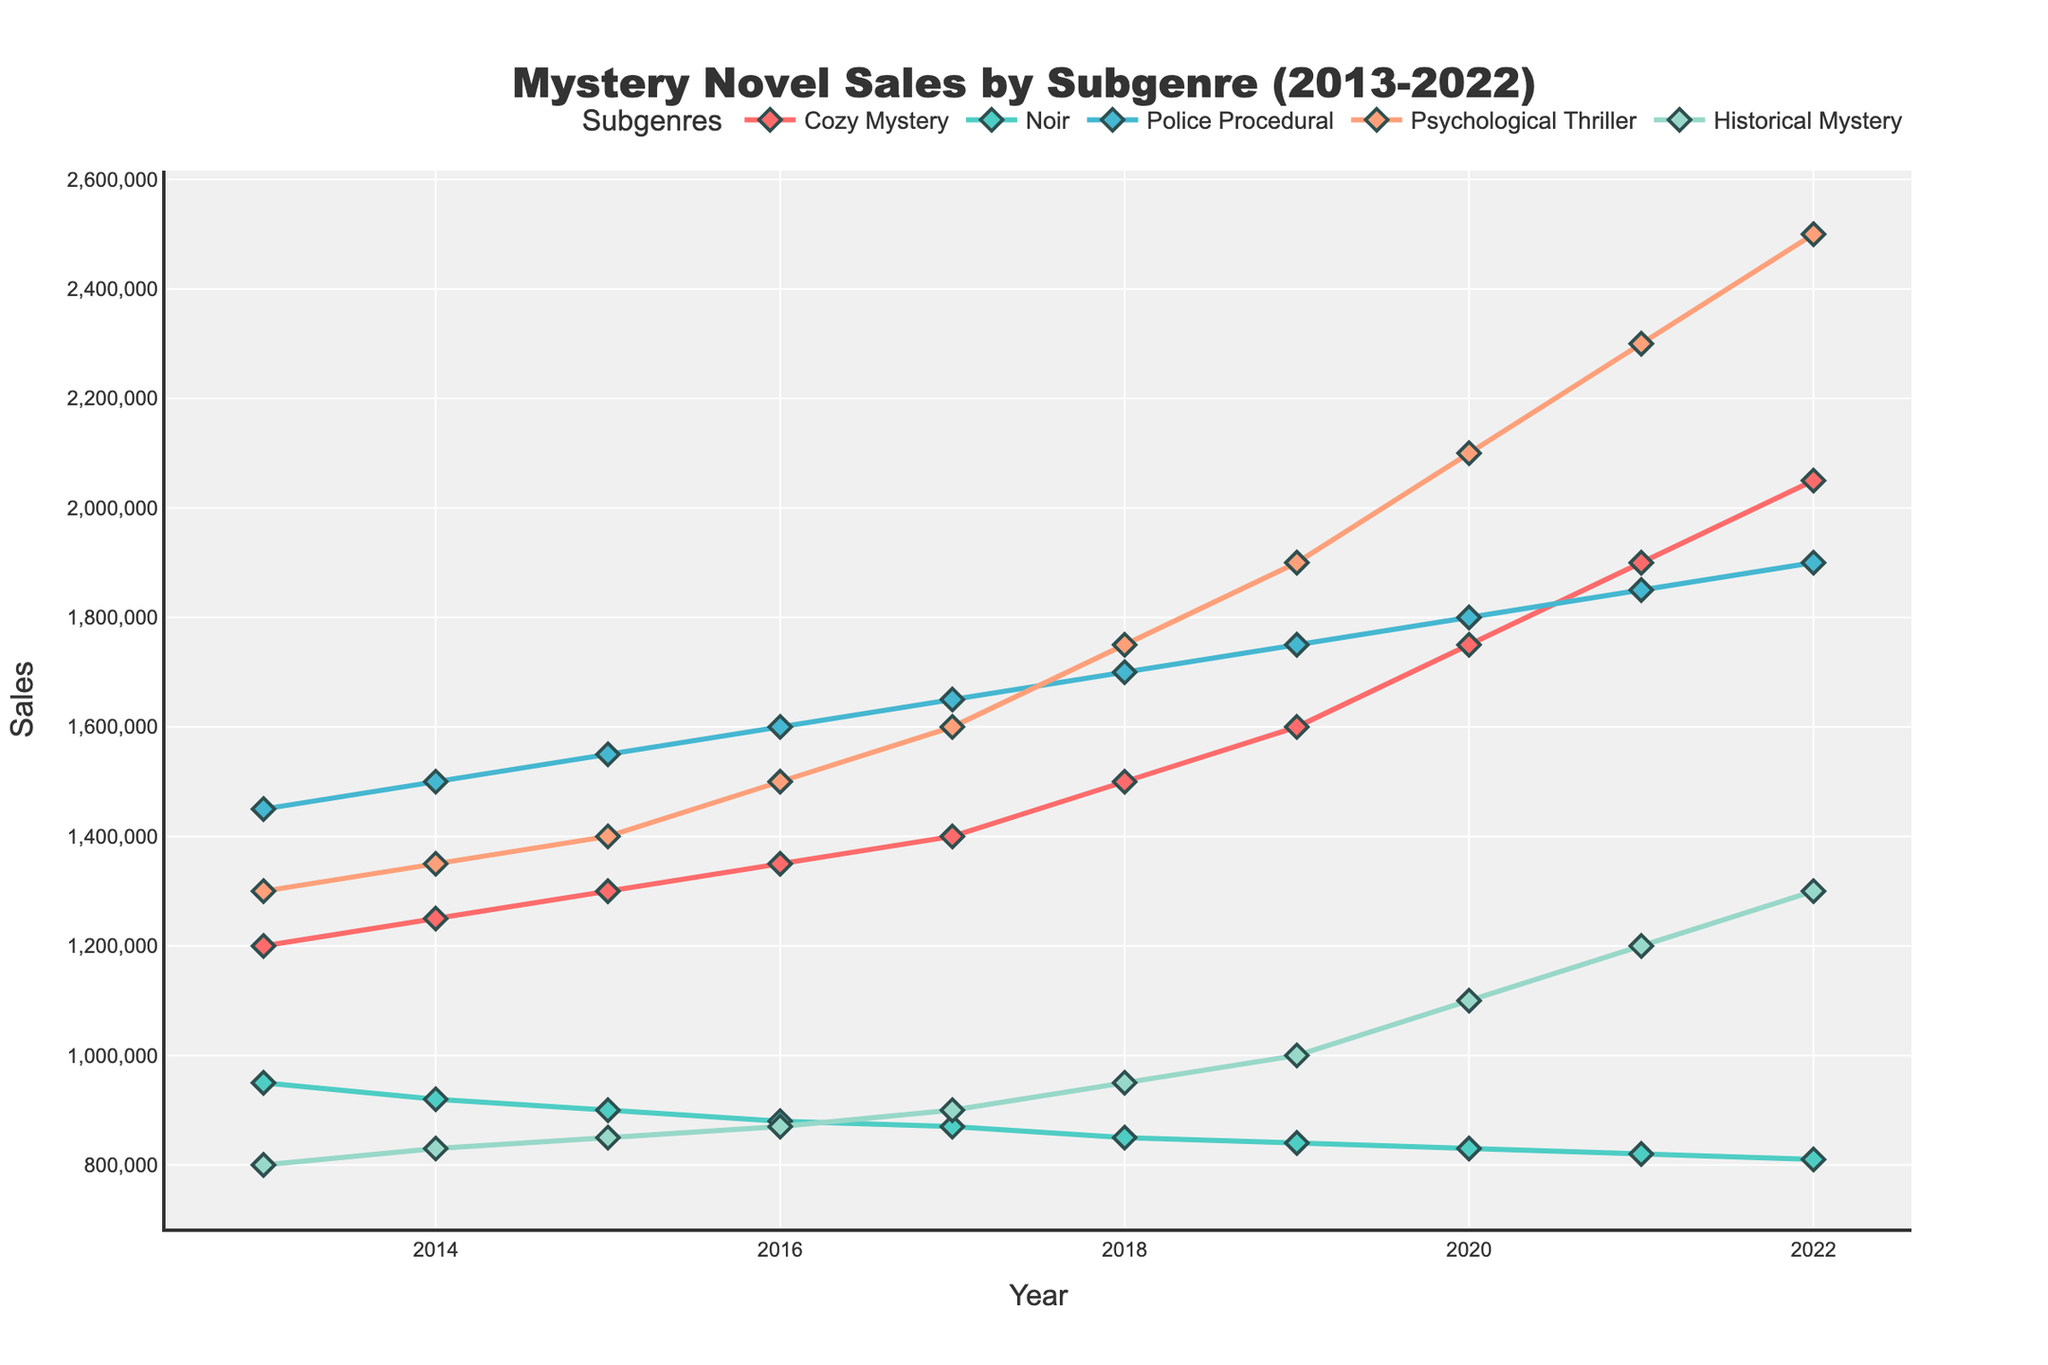What's the average yearly sales of the Cozy Mystery subgenre from 2013 to 2022? Sum up the sales from 2013 to 2022 for Cozy Mystery: (1,200,000 + 1,250,000 + 1,300,000 + 1,350,000 + 1,400,000 + 1,500,000 + 1,600,000 + 1,750,000 + 1,900,000 + 2,050,000) = 15,300,000. Divide by the number of years (10): 15,300,000 / 10 = 1,530,000
Answer: 1,530,000 Which subgenre had the highest sales in 2022? Look at the sales figures for all subgenres in 2022. The Psychological Thriller subgenre had the highest sales at 2,500,000.
Answer: Psychological Thriller What is the trend in sales for the Noir subgenre from 2013 to 2022? The plot shows that sales for the Noir subgenre have been declining each year. Starting from 950,000 in 2013 to 810,000 in 2022.
Answer: Declining By how much did sales of Historical Mystery increase from 2013 to 2022? Historical Mystery sales in 2022 were 1,300,000 and in 2013 were 800,000. The increase is 1,300,000 - 800,000 = 500,000.
Answer: 500,000 Which subgenre showed the most consistent increase in sales over the decade? Look for the subgenre with steady annual increments in the chart. Cozy Mystery sales increase every year consistently without fluctuations.
Answer: Cozy Mystery What was the total sales for Police Procedural over the entire decade? Sum up the Police Procedural sales from 2013 to 2022: (1,450,000 + 1,500,000 + 1,550,000 + 1,600,000 + 1,650,000 + 1,700,000 + 1,750,000 + 1,800,000 + 1,850,000 + 1,900,000) = 17,750,000.
Answer: 17,750,000 Between 2016 and 2019, which subgenre’s sales increased the most? Calculate the sales increase for each subgenre between 2016 and 2019 and compare: Cozy Mystery (1,600,000 - 1,350,000 = 250,000), Noir (840,000 - 880,000 = -40,000), Police Procedural (1,750,000 - 1,600,000 = 150,000), Psychological Thriller (1,900,000 - 1,500,000 = 400,000), Historical Mystery (1,000,000 - 870,000 = 130,000). Psychological Thriller had the highest increase (400,000).
Answer: Psychological Thriller In what year did Cozy Mystery sales surpass 1,500,000? Observe the sales trend line for Cozy Mystery. The sales surpass 1,500,000 in 2018.
Answer: 2018 What were the sales for Psychological Thriller in 2015 compared to 2021? Psychological Thriller sales in 2015 were 1,400,000 and in 2021 were 2,300,000. The difference is 2,300,000 - 1,400,000 = 900,000.
Answer: 900,000 